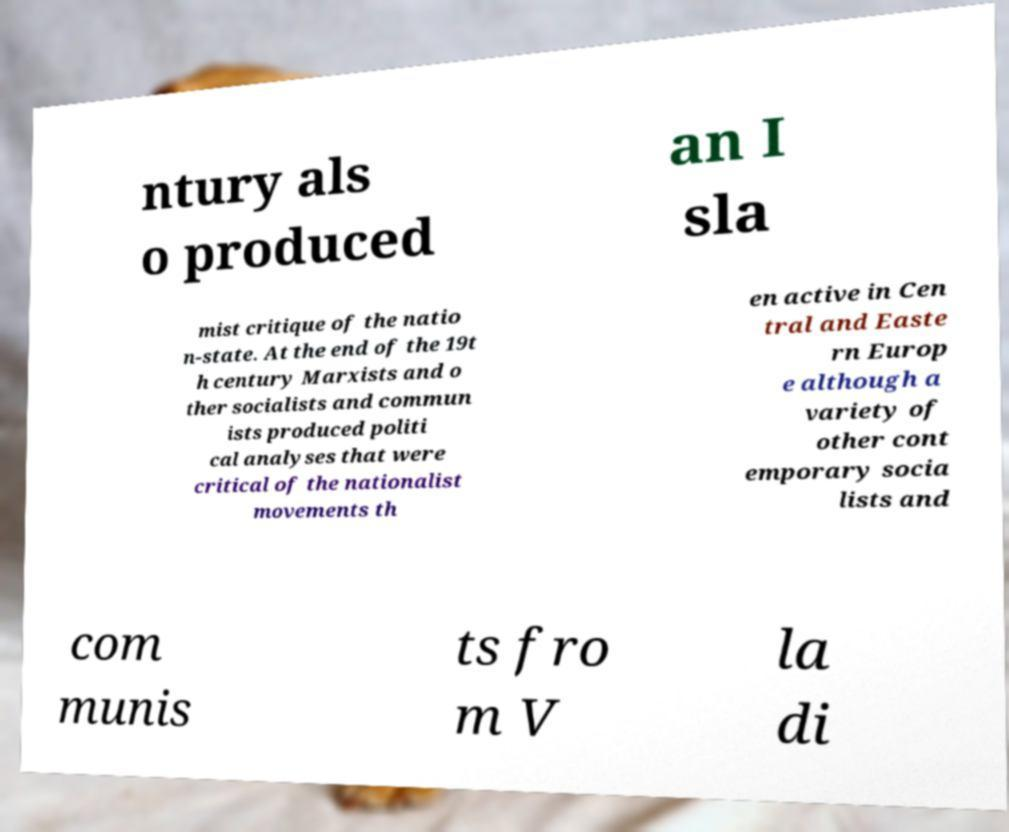Could you extract and type out the text from this image? ntury als o produced an I sla mist critique of the natio n-state. At the end of the 19t h century Marxists and o ther socialists and commun ists produced politi cal analyses that were critical of the nationalist movements th en active in Cen tral and Easte rn Europ e although a variety of other cont emporary socia lists and com munis ts fro m V la di 